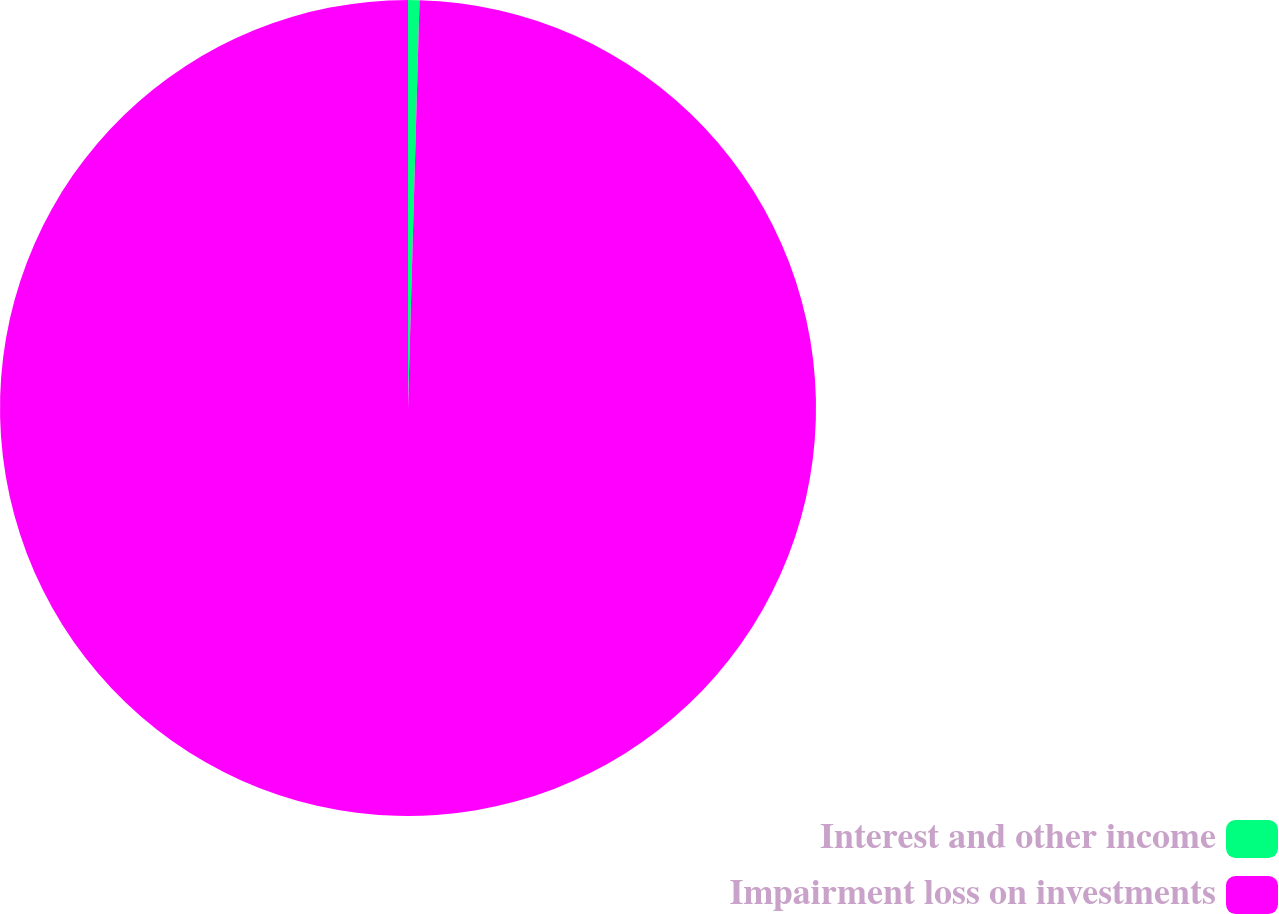<chart> <loc_0><loc_0><loc_500><loc_500><pie_chart><fcel>Interest and other income<fcel>Impairment loss on investments<nl><fcel>0.45%<fcel>99.55%<nl></chart> 